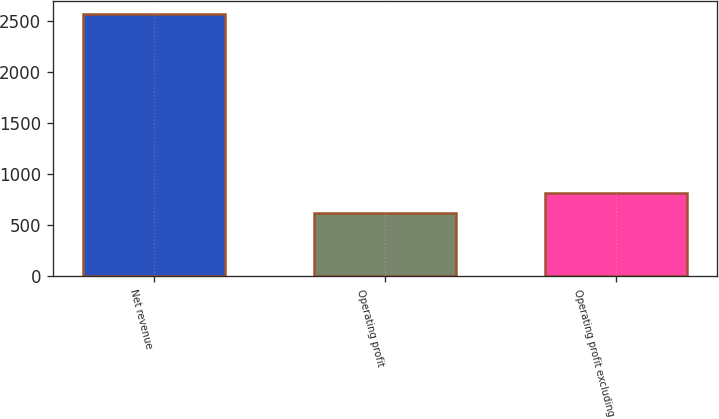Convert chart to OTSL. <chart><loc_0><loc_0><loc_500><loc_500><bar_chart><fcel>Net revenue<fcel>Operating profit<fcel>Operating profit excluding<nl><fcel>2568<fcel>621<fcel>815.7<nl></chart> 